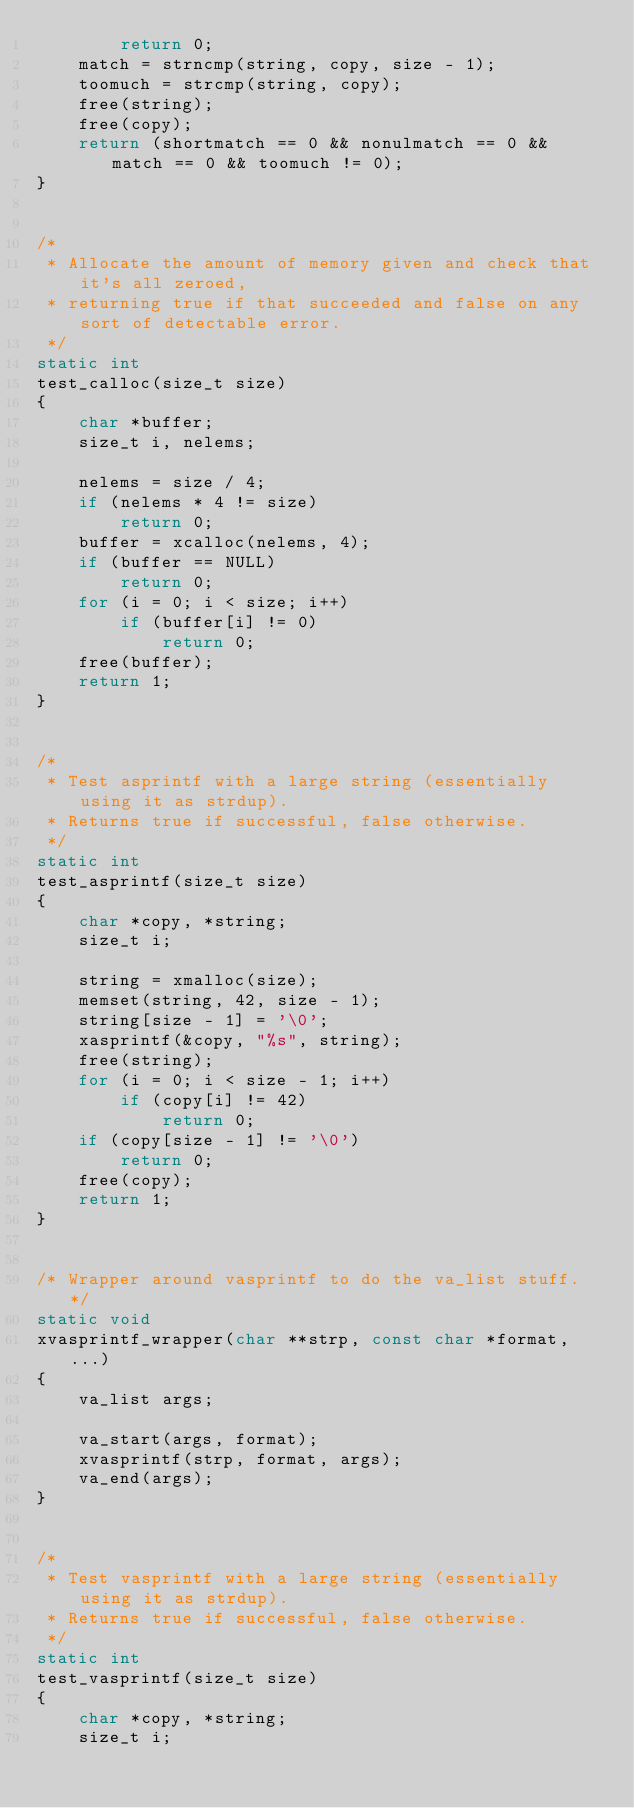Convert code to text. <code><loc_0><loc_0><loc_500><loc_500><_C_>        return 0;
    match = strncmp(string, copy, size - 1);
    toomuch = strcmp(string, copy);
    free(string);
    free(copy);
    return (shortmatch == 0 && nonulmatch == 0 && match == 0 && toomuch != 0);
}


/*
 * Allocate the amount of memory given and check that it's all zeroed,
 * returning true if that succeeded and false on any sort of detectable error.
 */
static int
test_calloc(size_t size)
{
    char *buffer;
    size_t i, nelems;

    nelems = size / 4;
    if (nelems * 4 != size)
        return 0;
    buffer = xcalloc(nelems, 4);
    if (buffer == NULL)
        return 0;
    for (i = 0; i < size; i++)
        if (buffer[i] != 0)
            return 0;
    free(buffer);
    return 1;
}


/*
 * Test asprintf with a large string (essentially using it as strdup).
 * Returns true if successful, false otherwise.
 */
static int
test_asprintf(size_t size)
{
    char *copy, *string;
    size_t i;

    string = xmalloc(size);
    memset(string, 42, size - 1);
    string[size - 1] = '\0';
    xasprintf(&copy, "%s", string);
    free(string);
    for (i = 0; i < size - 1; i++)
        if (copy[i] != 42)
            return 0;
    if (copy[size - 1] != '\0')
        return 0;
    free(copy);
    return 1;
}


/* Wrapper around vasprintf to do the va_list stuff. */
static void
xvasprintf_wrapper(char **strp, const char *format, ...)
{
    va_list args;

    va_start(args, format);
    xvasprintf(strp, format, args);
    va_end(args);
}


/*
 * Test vasprintf with a large string (essentially using it as strdup).
 * Returns true if successful, false otherwise.
 */
static int
test_vasprintf(size_t size)
{
    char *copy, *string;
    size_t i;
</code> 